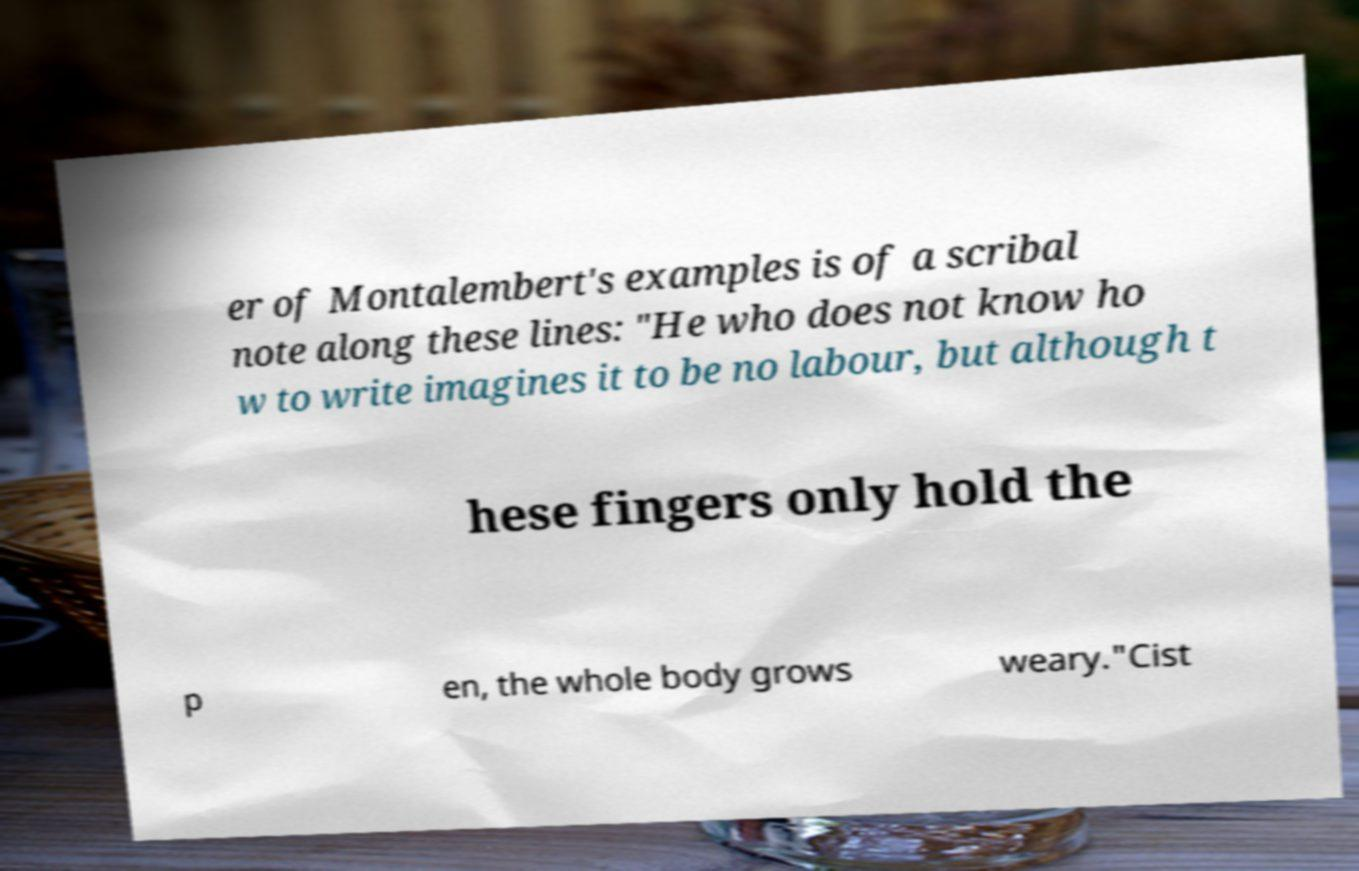Could you assist in decoding the text presented in this image and type it out clearly? er of Montalembert's examples is of a scribal note along these lines: "He who does not know ho w to write imagines it to be no labour, but although t hese fingers only hold the p en, the whole body grows weary."Cist 